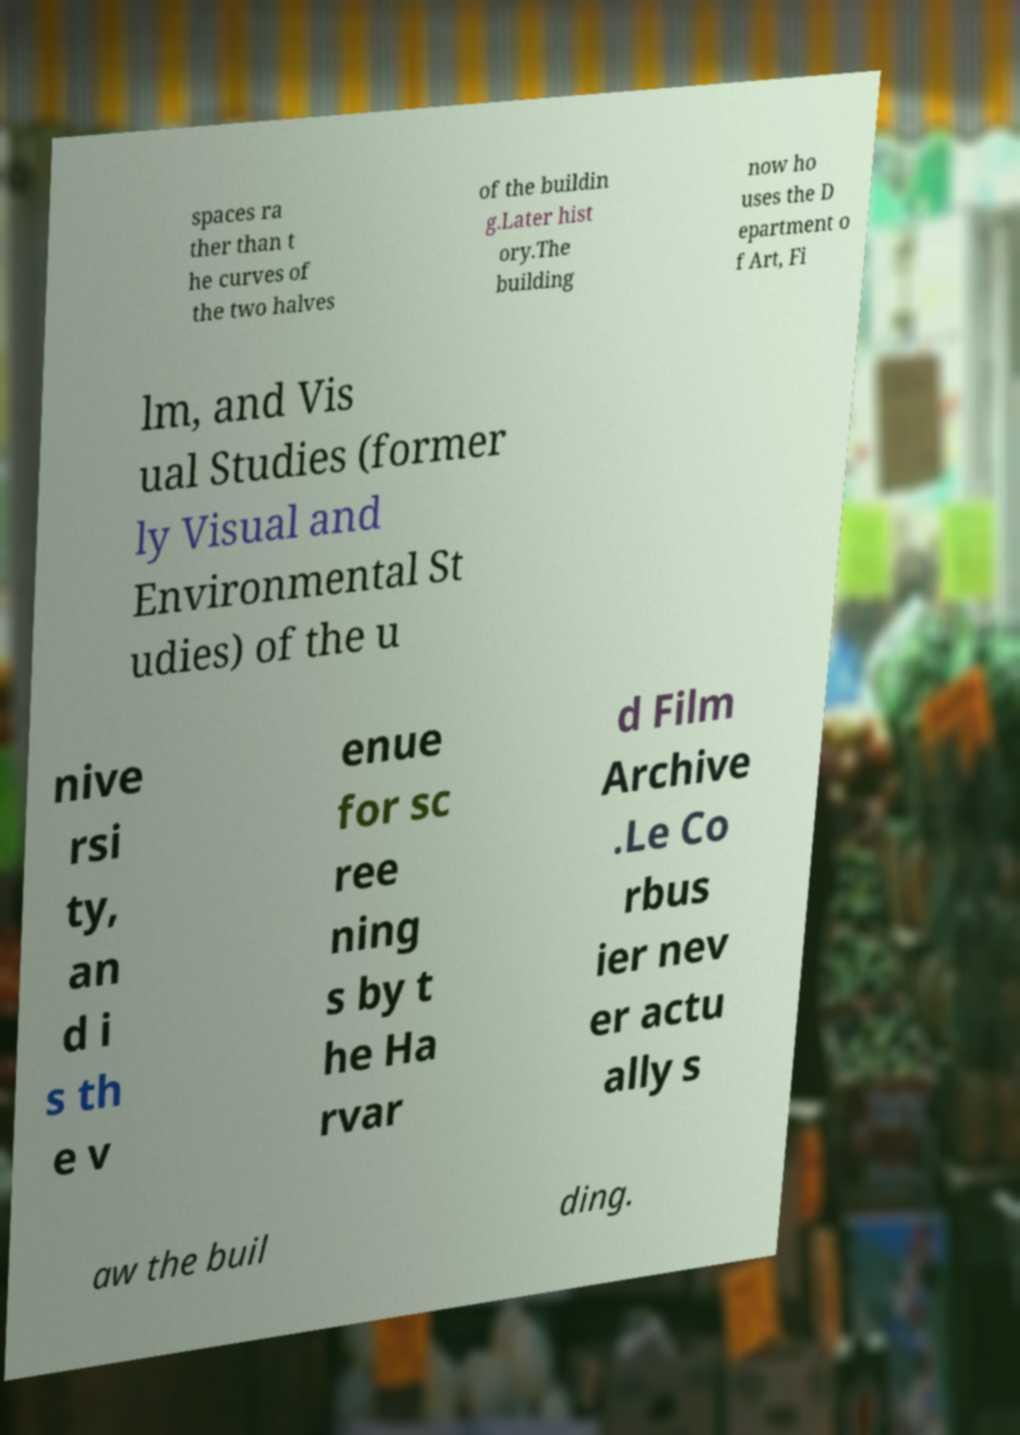Could you extract and type out the text from this image? spaces ra ther than t he curves of the two halves of the buildin g.Later hist ory.The building now ho uses the D epartment o f Art, Fi lm, and Vis ual Studies (former ly Visual and Environmental St udies) of the u nive rsi ty, an d i s th e v enue for sc ree ning s by t he Ha rvar d Film Archive .Le Co rbus ier nev er actu ally s aw the buil ding. 